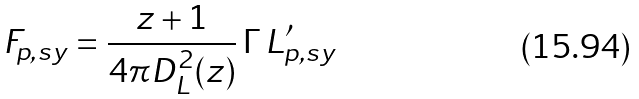<formula> <loc_0><loc_0><loc_500><loc_500>F _ { p , s y } = \frac { z + 1 } { 4 \pi D _ { L } ^ { 2 } ( z ) } \, \Gamma \, L ^ { \prime } _ { p , s y }</formula> 